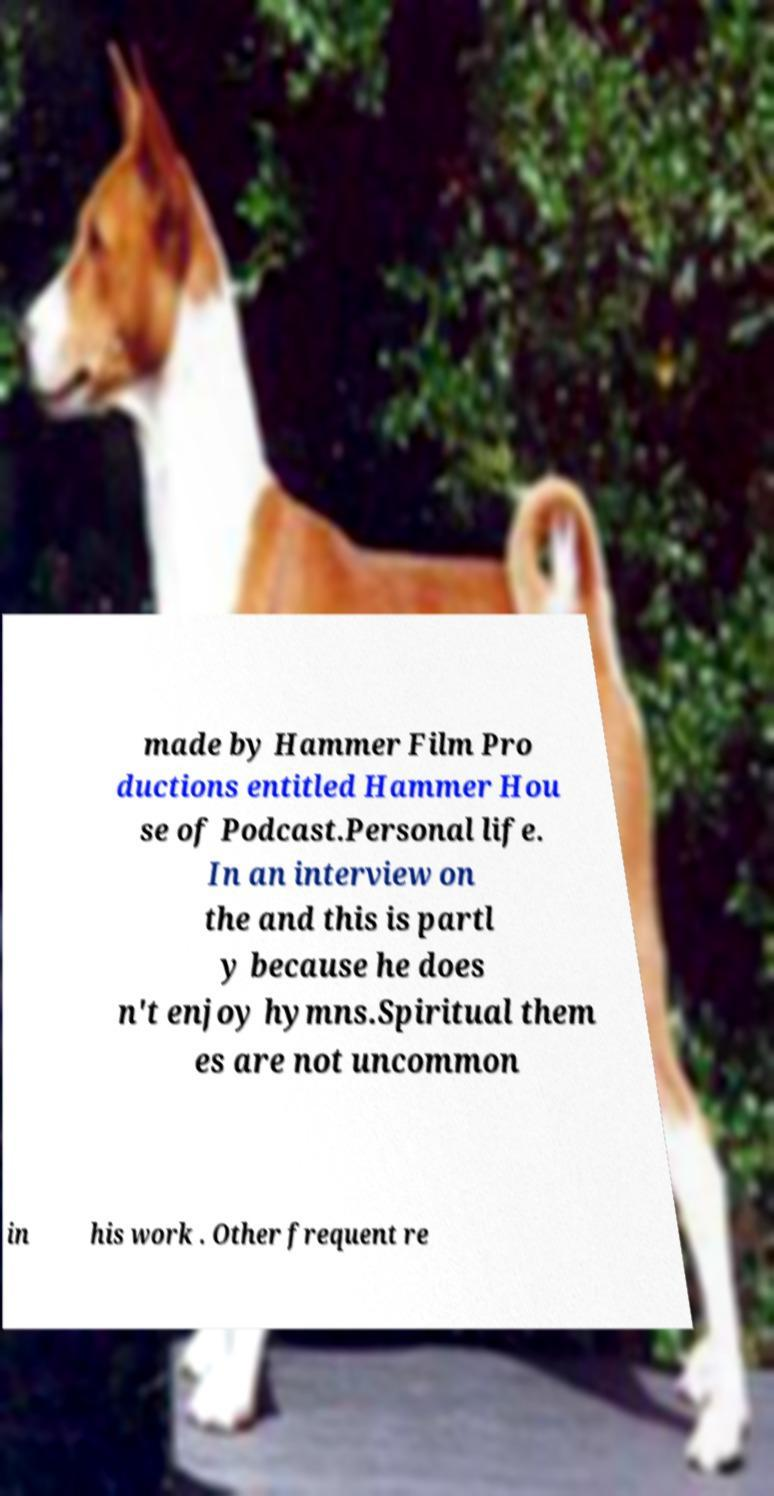There's text embedded in this image that I need extracted. Can you transcribe it verbatim? made by Hammer Film Pro ductions entitled Hammer Hou se of Podcast.Personal life. In an interview on the and this is partl y because he does n't enjoy hymns.Spiritual them es are not uncommon in his work . Other frequent re 